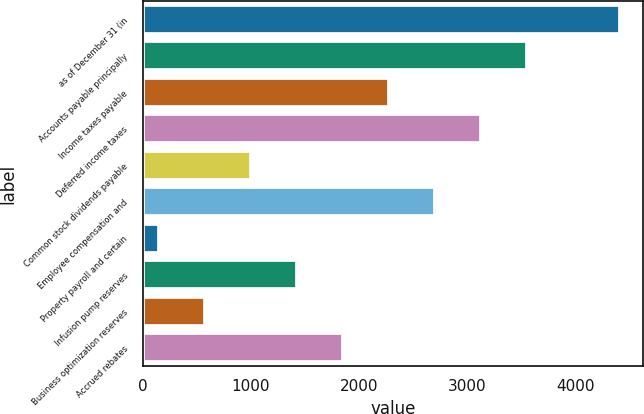Convert chart to OTSL. <chart><loc_0><loc_0><loc_500><loc_500><bar_chart><fcel>as of December 31 (in<fcel>Accounts payable principally<fcel>Income taxes payable<fcel>Deferred income taxes<fcel>Common stock dividends payable<fcel>Employee compensation and<fcel>Property payroll and certain<fcel>Infusion pump reserves<fcel>Business optimization reserves<fcel>Accrued rebates<nl><fcel>4411<fcel>3558.8<fcel>2280.5<fcel>3132.7<fcel>1002.2<fcel>2706.6<fcel>150<fcel>1428.3<fcel>576.1<fcel>1854.4<nl></chart> 